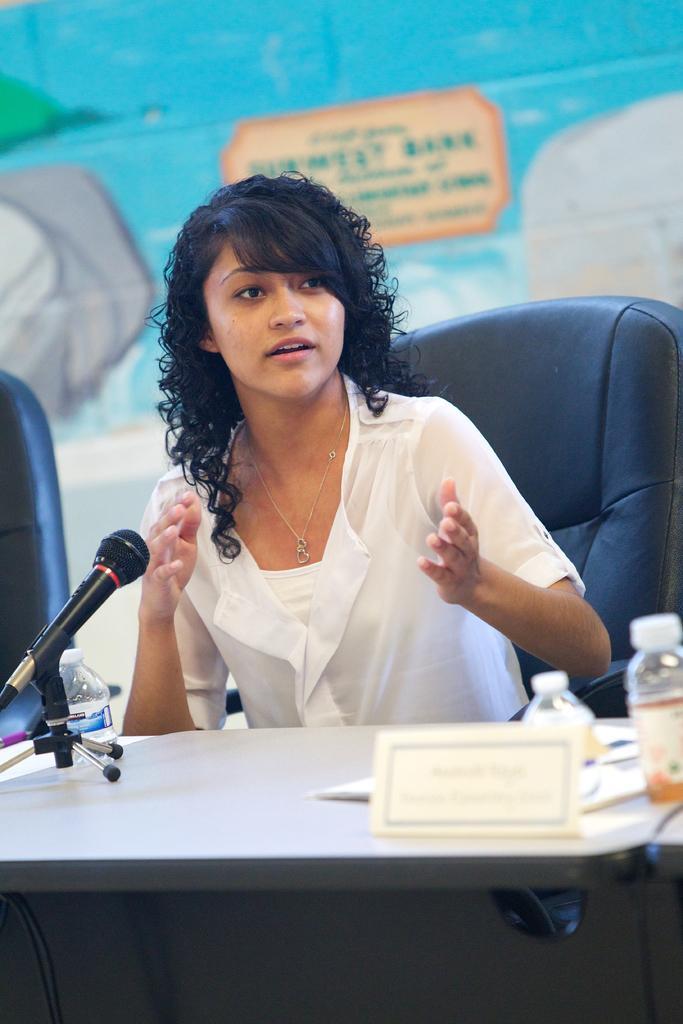Could you give a brief overview of what you see in this image? In this image I see a woman who is sitting on the chair and there is a table in front of her. I can also see that there are 3 bottles and a mic. 